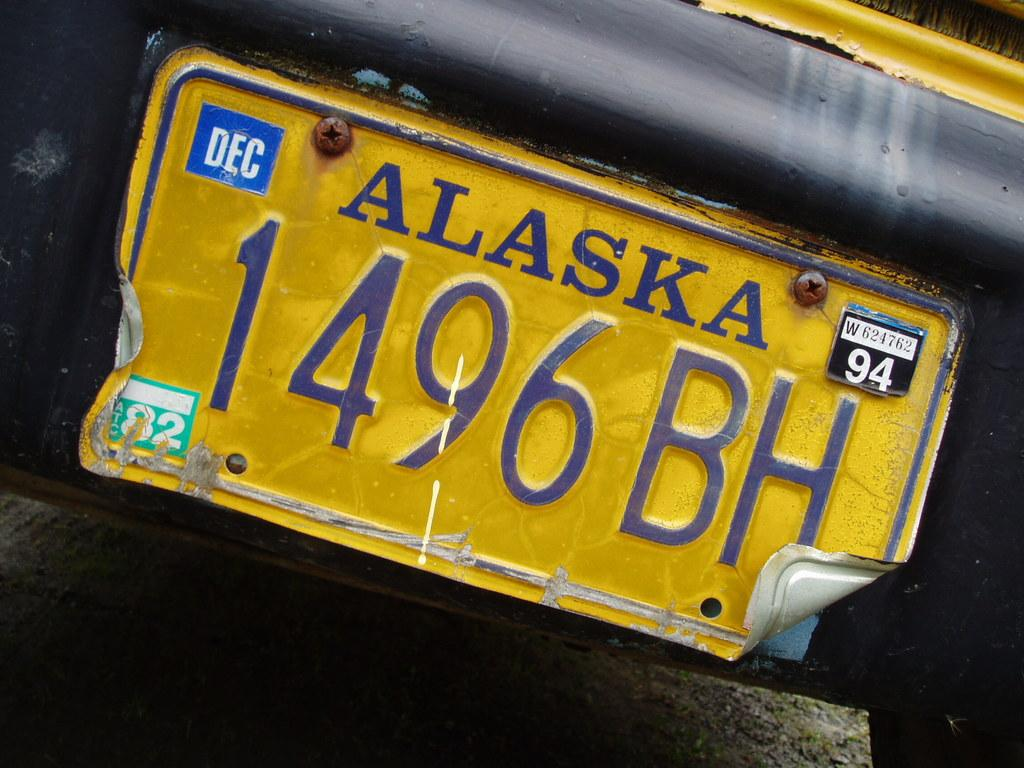<image>
Offer a succinct explanation of the picture presented. A yellow Alaska license plate that has 94 in the top right and 1496BH in the middle with a bent lower right corner. 